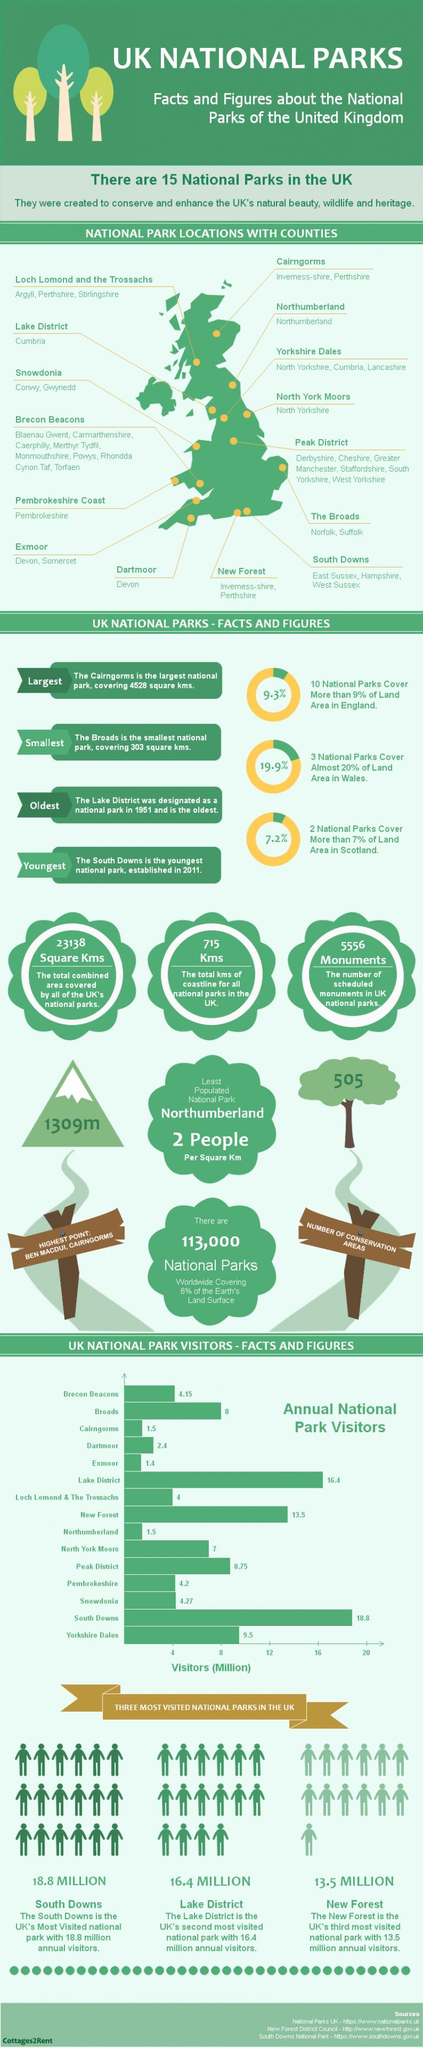Indicate a few pertinent items in this graphic. The total combined area covered by all of the UK's national parks is approximately 23,138 square kilometers. The total length of coastline for all national parks in the United Kingdom is 715 kilometers. The Northumberland National Park was visited by 1.5 million people in (year). In the North York Moors National Park, approximately 7 million people visited in (year). There are 5,556 scheduled monuments in UK national parks. 